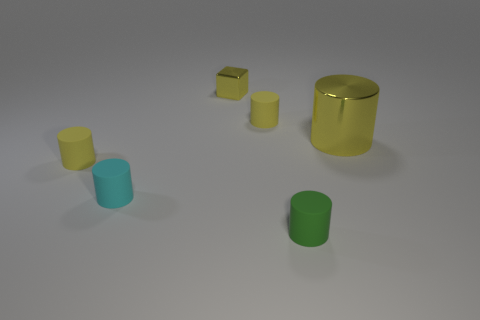Add 2 yellow objects. How many objects exist? 8 Subtract all small yellow cylinders. How many cylinders are left? 3 Subtract all cyan cylinders. How many cylinders are left? 4 Subtract 3 cylinders. How many cylinders are left? 2 Subtract all yellow metal blocks. Subtract all tiny yellow metallic objects. How many objects are left? 4 Add 5 yellow matte things. How many yellow matte things are left? 7 Add 1 cyan objects. How many cyan objects exist? 2 Subtract 1 yellow blocks. How many objects are left? 5 Subtract all cubes. How many objects are left? 5 Subtract all gray cylinders. Subtract all red cubes. How many cylinders are left? 5 